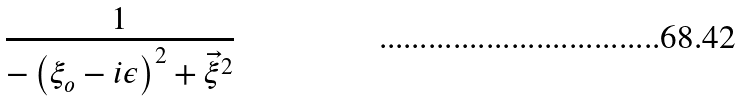<formula> <loc_0><loc_0><loc_500><loc_500>\frac { 1 } { - \left ( \xi _ { o } - i \epsilon \right ) ^ { 2 } + \vec { \xi } ^ { 2 } }</formula> 